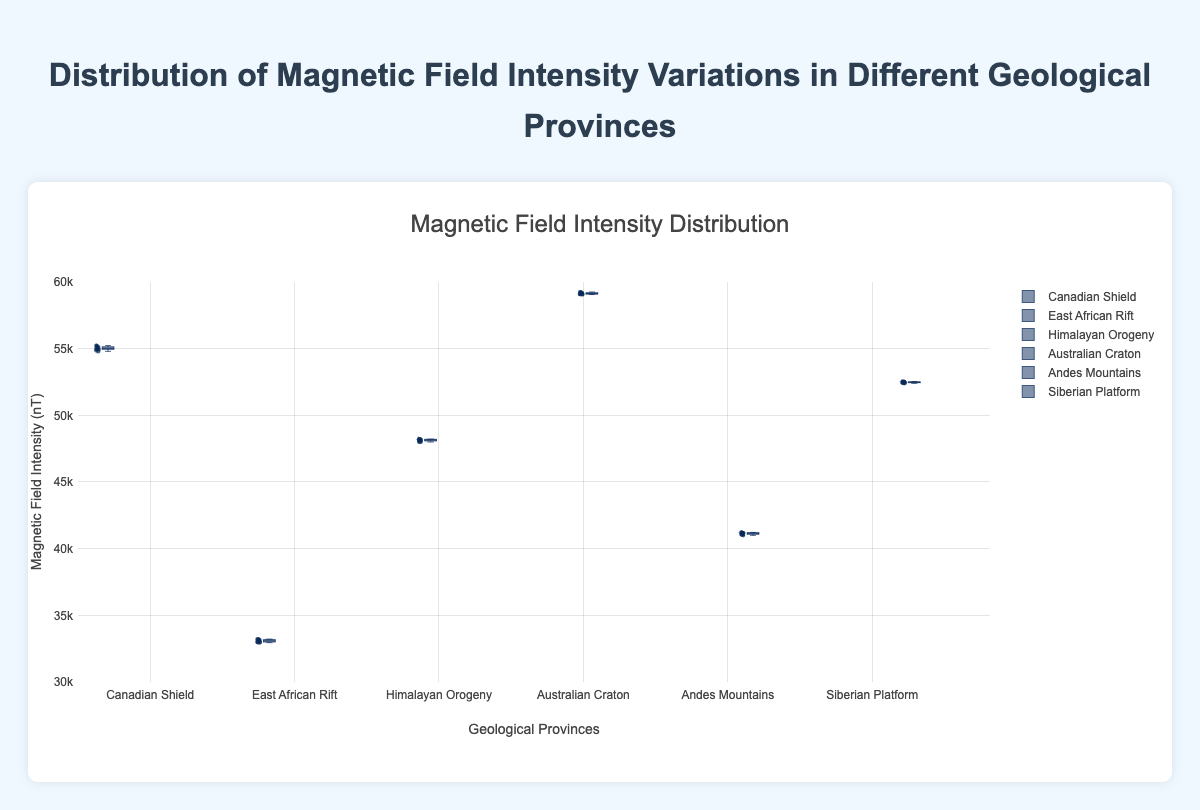What's the title of the figure? The title of the figure is located at the top and provides a description of what the chart represents.
Answer: Distribution of Magnetic Field Intensity Variations in Different Geological Provinces What does the y-axis represent? The y-axis label indicates the variable being measured or represented in the chart.
Answer: Magnetic Field Intensity (nT) Which geological province has the highest median magnetic field intensity? To find this, look at the central line inside each box in the box plots, which represents the median value of the dataset.
Answer: Australian Craton Which geological province has the smallest range of magnetic field intensity? The range can be determined by the distance between the minimum and maximum whiskers for each box plot. The smallest range will have the shortest distance between these whiskers.
Answer: East African Rift How many geological provinces are compared in this figure? Count the number of distinct box plots, each labeled with the name of a geological province.
Answer: Six What is the median magnetic field intensity for the East African Rift? Look at the middle line of the East African Rift's box, which represents the median value of the data points.
Answer: 33100 nT Comparing the Canadian Shield and the Andes Mountains, which geological province has a higher interquartile range (IQR)? The interquartile range (IQR) is the distance between the first quartile (bottom of the box) and the third quartile (top of the box). Compare the box heights of the Canadian Shield and Andes Mountains.
Answer: Canadian Shield What is the approximate range of values for the Himalayan Orogeny? Determine the range by subtracting the minimum whisker value from the maximum whisker value for the Himalayan Orogeny box plot.
Answer: Approximately 48000 to 48220 nT Which two geological provinces have overlapping ranges of magnetic field intensity? Look for box plots where the whiskers (or the ends of the boxes) overlap on the y-axis.
Answer: Siberian Platform and Canadian Shield How does the overall magnetic field intensity distribution vary across different geological provinces? Assess the spread, central tendency, and range of magnetic field intensities by examining the positions and spreads of the box plots across all provinces.
Answer: Varies widely: Australian Craton has the highest intensities and East African Rift the lowest; distributions have varying spreads and median values 